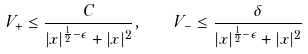Convert formula to latex. <formula><loc_0><loc_0><loc_500><loc_500>V _ { + } \leq \frac { C } { | x | ^ { \frac { 1 } { 2 } - \epsilon } + | x | ^ { 2 } } , \quad V _ { - } \leq \frac { \delta } { | x | ^ { \frac { 1 } { 2 } - \epsilon } + | x | ^ { 2 } }</formula> 